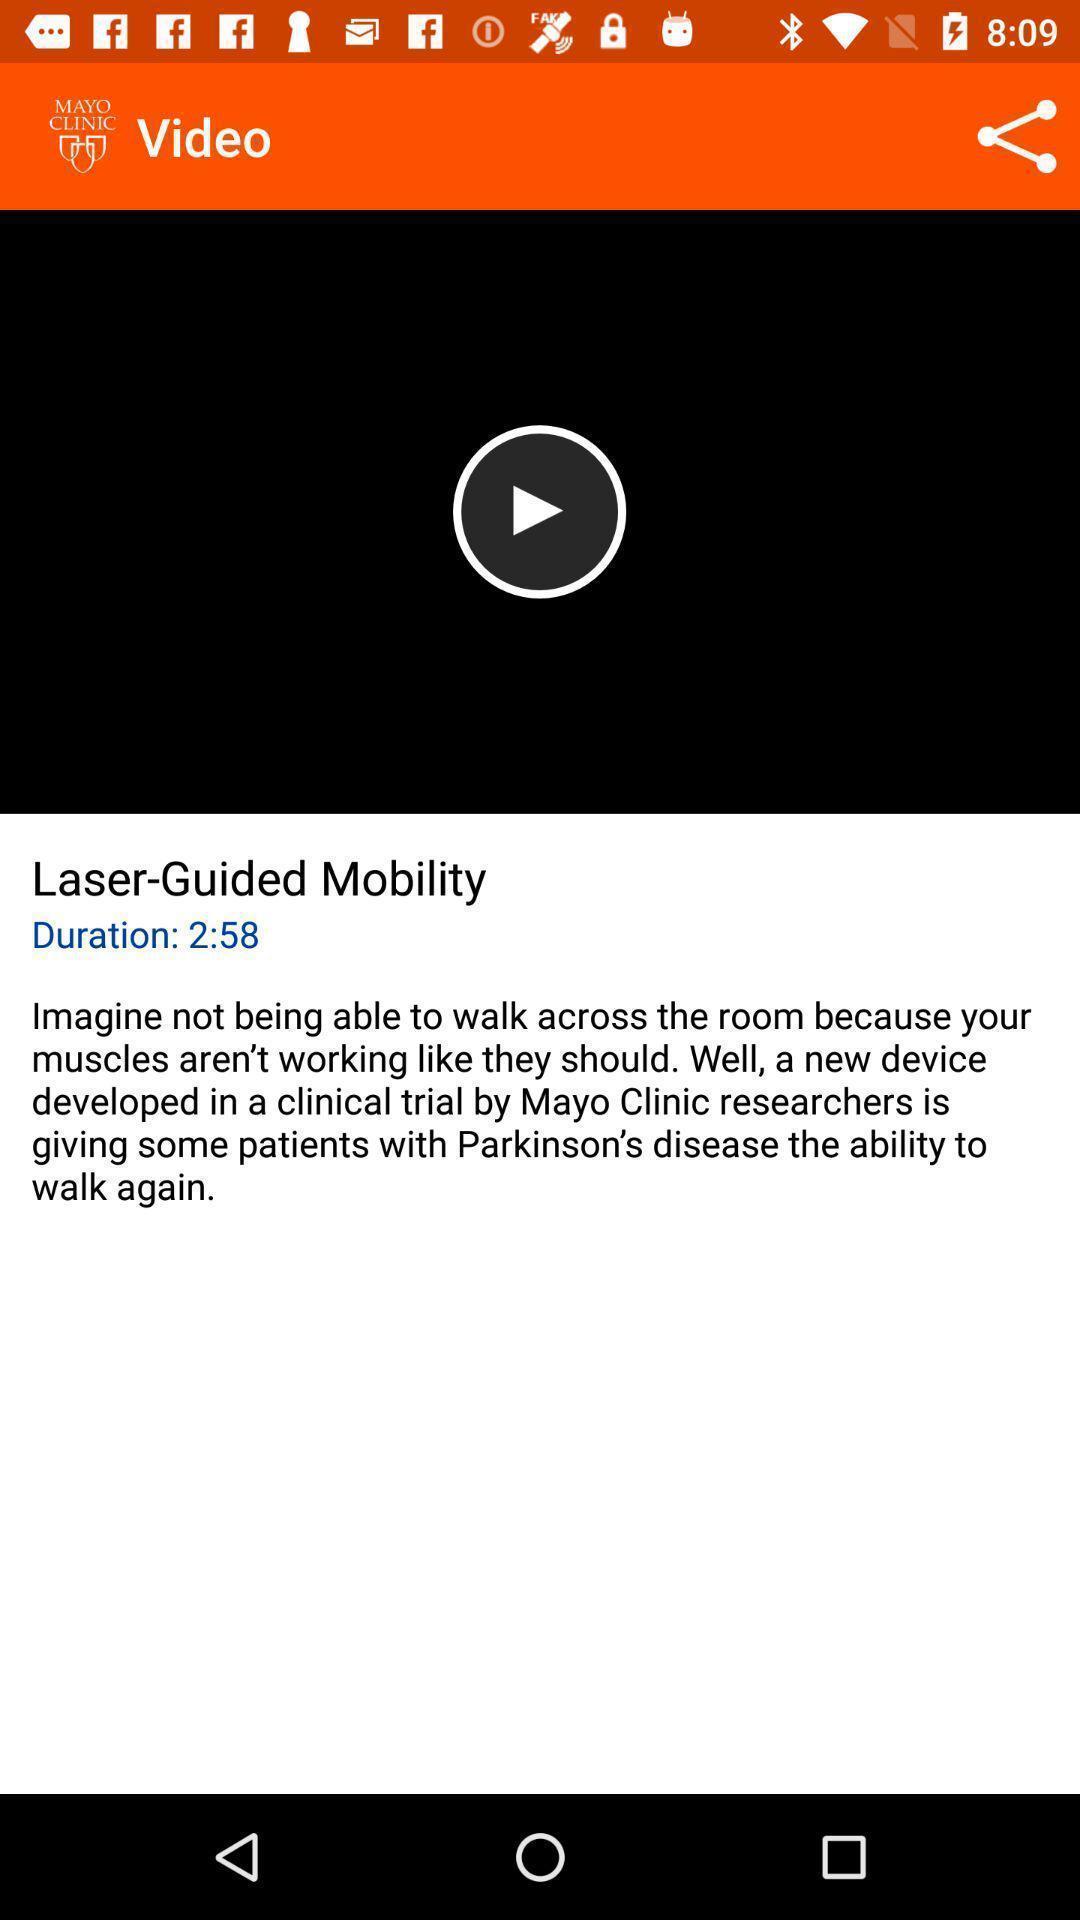Describe the content in this image. Screen displaying a video with duration time. 